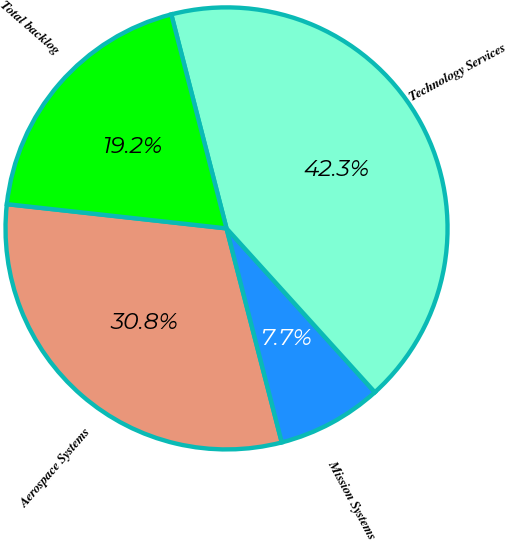<chart> <loc_0><loc_0><loc_500><loc_500><pie_chart><fcel>Aerospace Systems<fcel>Mission Systems<fcel>Technology Services<fcel>Total backlog<nl><fcel>30.77%<fcel>7.69%<fcel>42.31%<fcel>19.23%<nl></chart> 